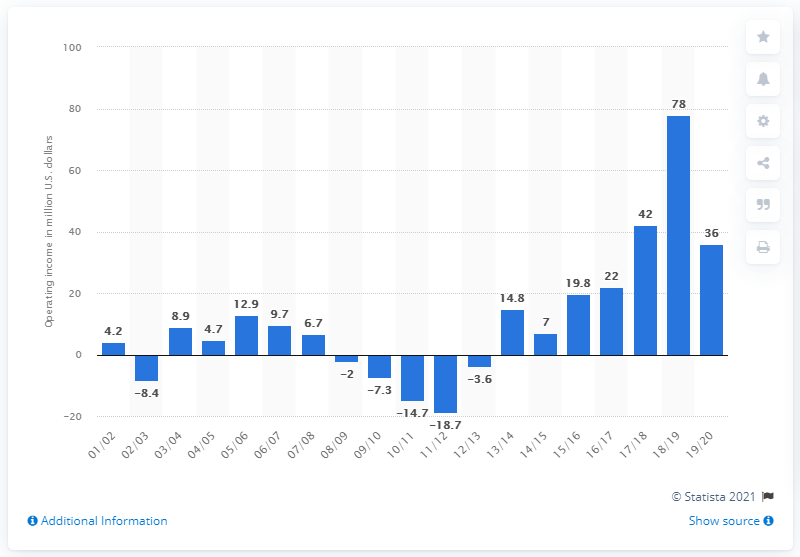Identify some key points in this picture. The operating income of the Atlanta Hawks in the 2019/20 season was $36 million. 